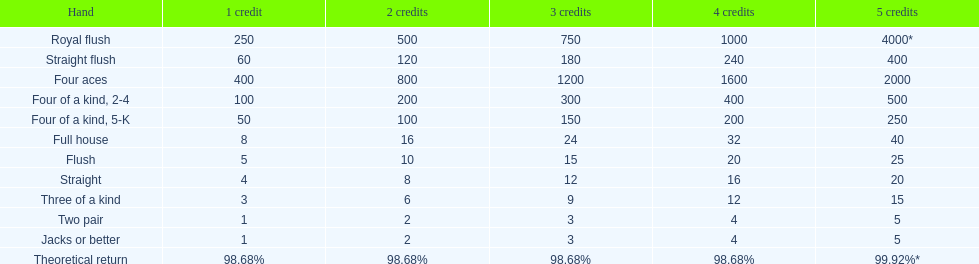How many credits must be spent to obtain a minimum payout of 2000 when possessing four aces? 5 credits. 